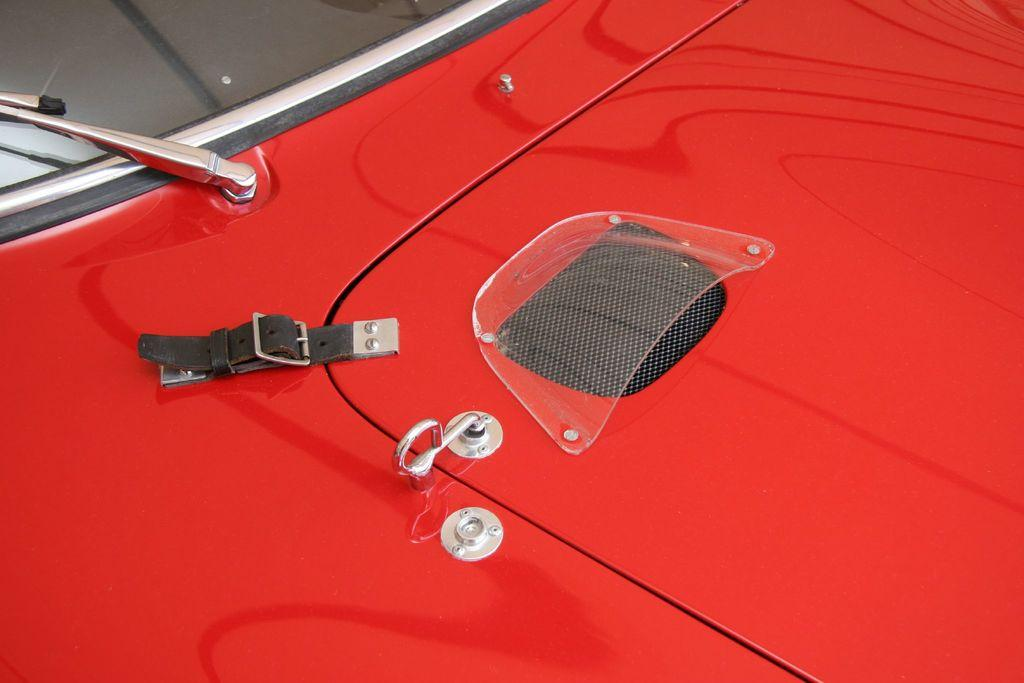What type of vehicle is visible in the image? The image contains the front part of a vehicle, but it does not specify the type of vehicle. Can you describe the visible features of the vehicle in the image? Unfortunately, the provided facts do not give enough information to describe the visible features of the vehicle. What type of development is taking place during the recess in the image? There is no information about development or recess in the image, as it only contains the front part of a vehicle. Can you see the lip of the driver in the image? There is no driver visible in the image, as it only contains the front part of a vehicle. 